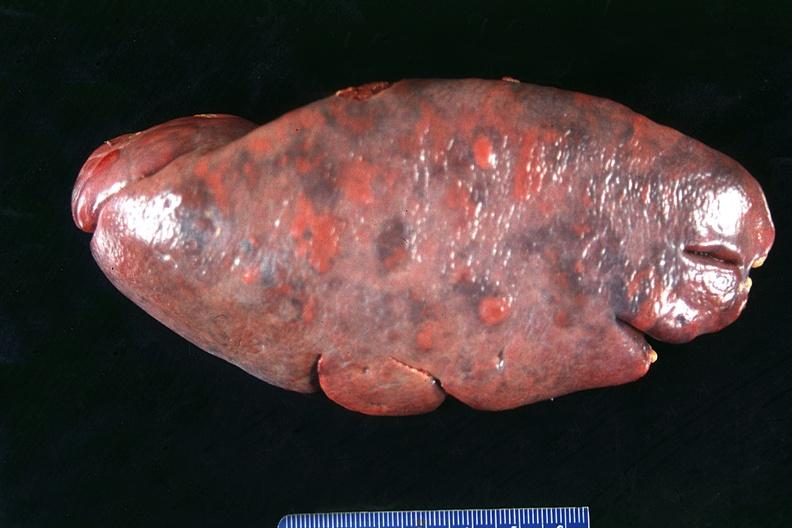does acrocyanosis show spleen, normal?
Answer the question using a single word or phrase. No 